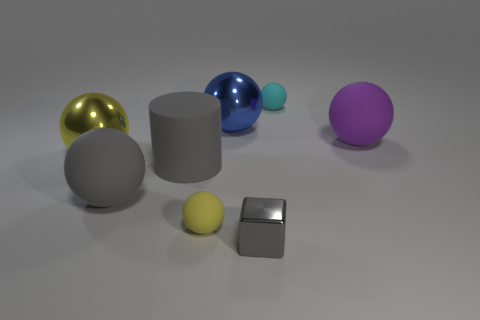Subtract all big yellow shiny balls. How many balls are left? 5 Subtract all gray balls. How many balls are left? 5 Subtract all brown balls. Subtract all green cylinders. How many balls are left? 6 Add 2 small gray things. How many objects exist? 10 Subtract all balls. How many objects are left? 2 Subtract all large gray objects. Subtract all gray rubber objects. How many objects are left? 4 Add 8 tiny yellow rubber things. How many tiny yellow rubber things are left? 9 Add 2 big metallic objects. How many big metallic objects exist? 4 Subtract 0 red spheres. How many objects are left? 8 